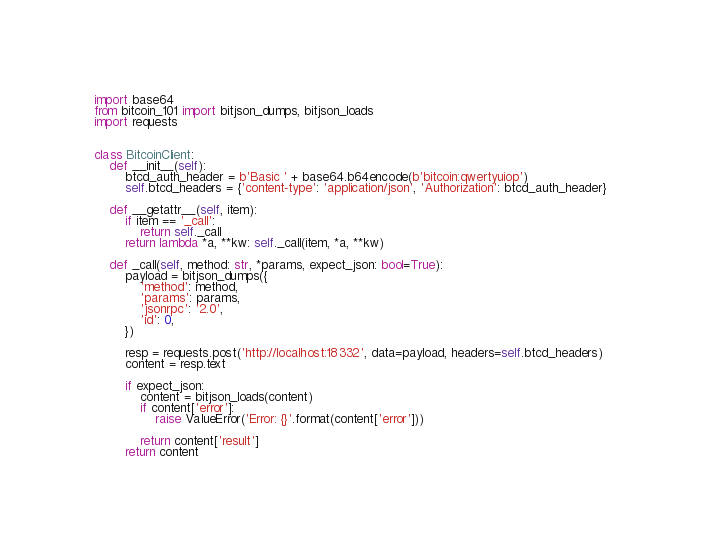<code> <loc_0><loc_0><loc_500><loc_500><_Python_>import base64
from bitcoin_101 import bitjson_dumps, bitjson_loads
import requests


class BitcoinClient:
    def __init__(self):
        btcd_auth_header = b'Basic ' + base64.b64encode(b'bitcoin:qwertyuiop')
        self.btcd_headers = {'content-type': 'application/json', 'Authorization': btcd_auth_header}

    def __getattr__(self, item):
        if item == '_call':
            return self._call
        return lambda *a, **kw: self._call(item, *a, **kw)

    def _call(self, method: str, *params, expect_json: bool=True):
        payload = bitjson_dumps({
            'method': method,
            'params': params,
            'jsonrpc': '2.0',
            'id': 0,
        })

        resp = requests.post('http://localhost:18332', data=payload, headers=self.btcd_headers)
        content = resp.text

        if expect_json:
            content = bitjson_loads(content)
            if content['error']:
                raise ValueError('Error: {}'.format(content['error']))

            return content['result']
        return content
</code> 